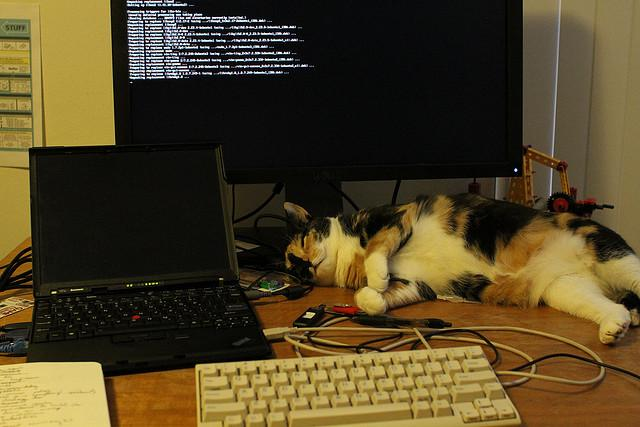How many computer screens are around the cat sleeping on the desk? Please explain your reasoning. two. Two monitors are present. 